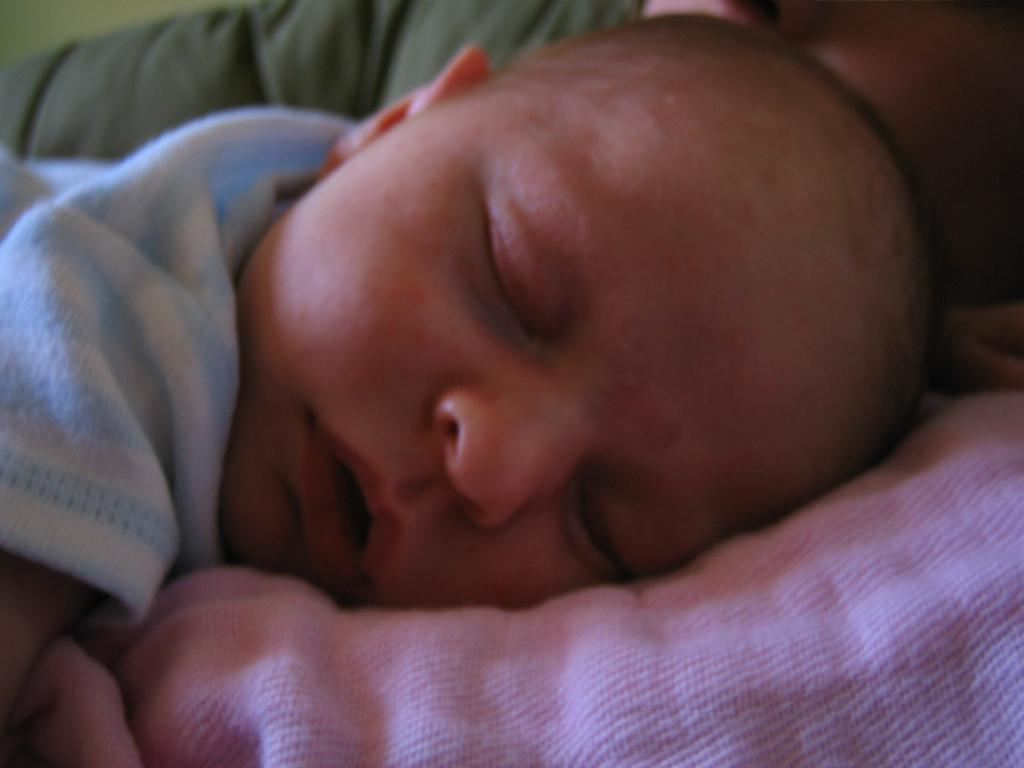What is the main subject of the image? The main subject of the image is an infant. What is the infant doing in the image? The infant is sleeping in the image. Where is the infant located in the image? The infant is on a bed sheet in the image. What type of knowledge is the infant gaining while sleeping in the image? The image does not provide information about the infant gaining knowledge while sleeping. 